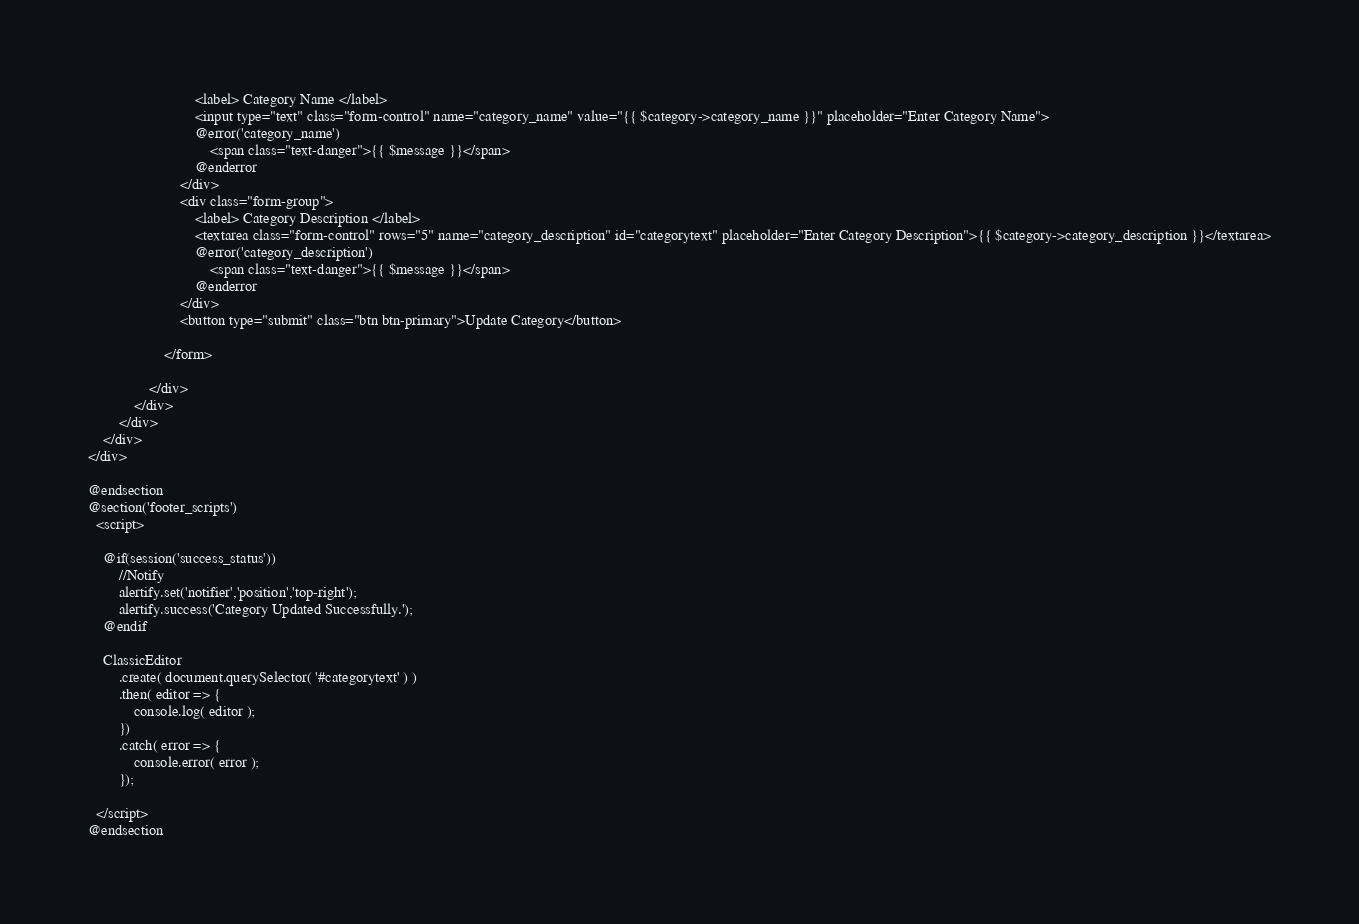Convert code to text. <code><loc_0><loc_0><loc_500><loc_500><_PHP_>						    <label> Category Name </label>
						    <input type="text" class="form-control" name="category_name" value="{{ $category->category_name }}" placeholder="Enter Category Name">
						    @error('category_name')
						    	<span class="text-danger">{{ $message }}</span>
						    @enderror
					  	</div>
					  	<div class="form-group">
						    <label> Category Description </label>
						    <textarea class="form-control" rows="5" name="category_description" id="categorytext" placeholder="Enter Category Description">{{ $category->category_description }}</textarea>
						    @error('category_description')
						    	<span class="text-danger">{{ $message }}</span>
						    @enderror
					  	</div>
				  	    <button type="submit" class="btn btn-primary">Update Category</button>

					</form>

				</div>
		  	</div>
		</div>
	</div>
</div>

@endsection
@section('footer_scripts')
  <script>

    @if(session('success_status'))
        //Notify
        alertify.set('notifier','position','top-right');
        alertify.success('Category Updated Successfully.');
    @endif

    ClassicEditor
        .create( document.querySelector( '#categorytext' ) )
        .then( editor => {
            console.log( editor );
        })
        .catch( error => {
            console.error( error );
        });

  </script>
@endsection
</code> 